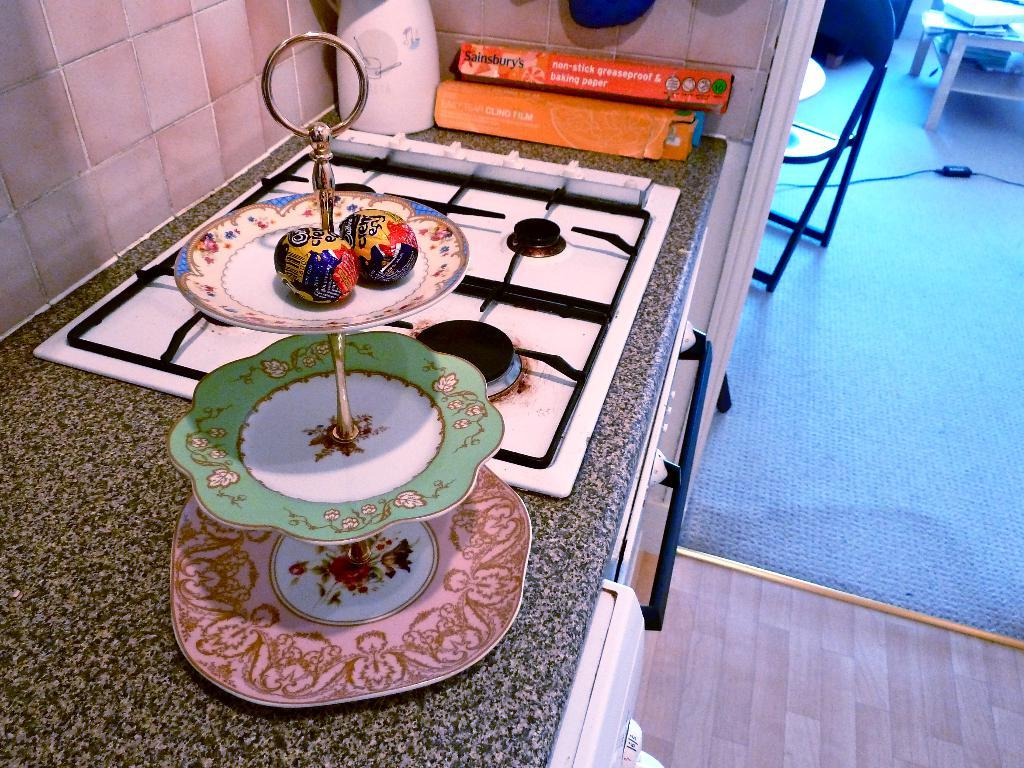What is the main subject in the image? There is an object in the image. Where is the object located? The object is placed on a table. What type of town can be seen in the image? There is no town present in the image; it only features an object placed on a table. How many wrens are visible in the image? There are no wrens present in the image. 